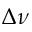Convert formula to latex. <formula><loc_0><loc_0><loc_500><loc_500>\Delta \nu</formula> 